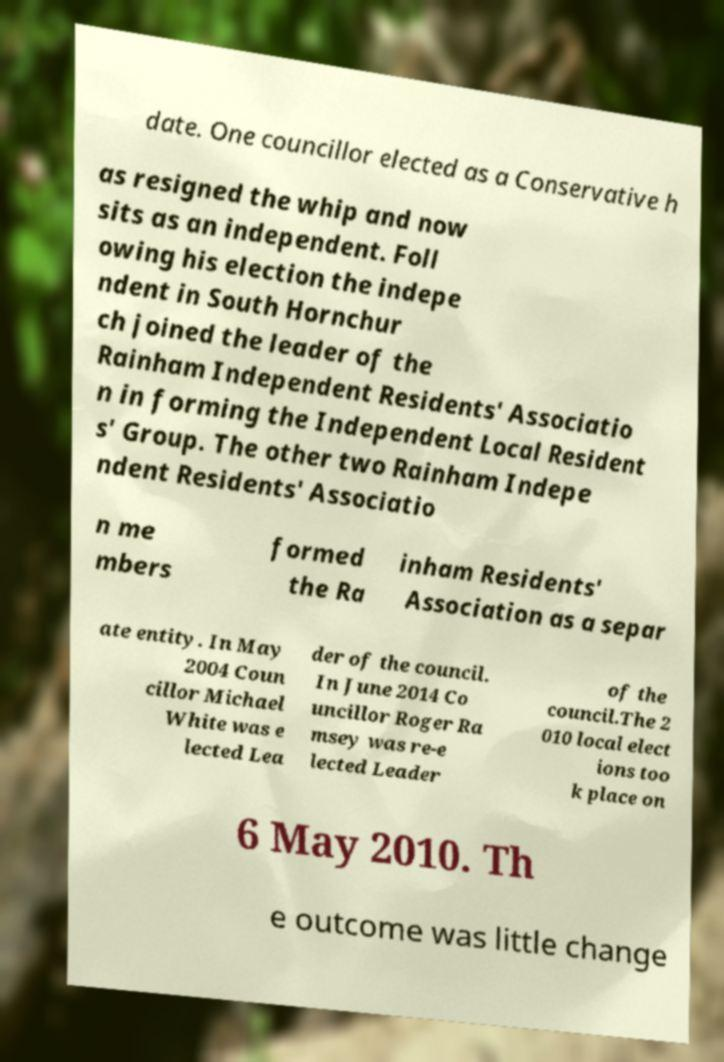I need the written content from this picture converted into text. Can you do that? date. One councillor elected as a Conservative h as resigned the whip and now sits as an independent. Foll owing his election the indepe ndent in South Hornchur ch joined the leader of the Rainham Independent Residents' Associatio n in forming the Independent Local Resident s' Group. The other two Rainham Indepe ndent Residents' Associatio n me mbers formed the Ra inham Residents' Association as a separ ate entity. In May 2004 Coun cillor Michael White was e lected Lea der of the council. In June 2014 Co uncillor Roger Ra msey was re-e lected Leader of the council.The 2 010 local elect ions too k place on 6 May 2010. Th e outcome was little change 